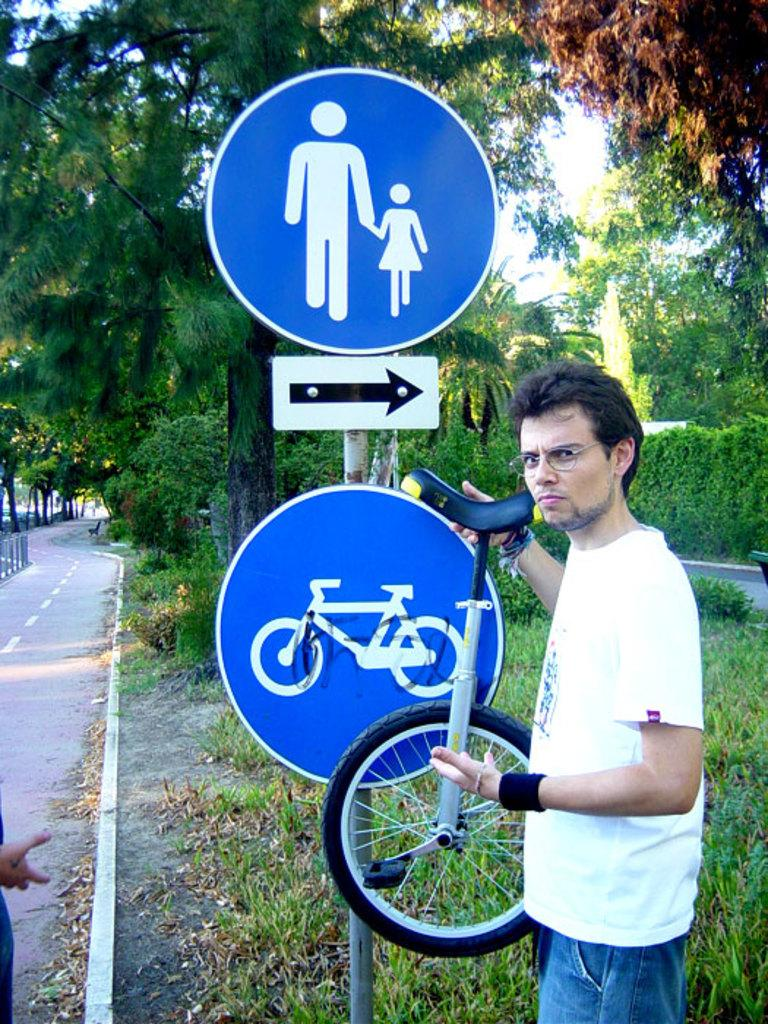Who is present in the image? There is a person in the image. What is the person holding in the image? The person is holding a unicycle bike. What type of natural environment can be seen in the image? There are trees visible in the image. What type of man-made structures are present in the image? There are sign boards attached to poles in the image. What type of butter is being used to grease the unicycle bike in the image? There is no butter present in the image, nor is there any indication that the unicycle bike needs to be greased. 